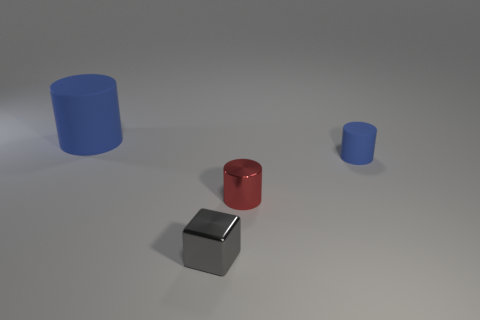Does the small gray block have the same material as the tiny red thing?
Offer a very short reply. Yes. What is the size of the other blue thing that is the same shape as the small matte object?
Provide a short and direct response. Large. Does the matte thing that is to the left of the small matte cylinder have the same shape as the tiny object that is to the left of the red cylinder?
Offer a terse response. No. Does the gray metal cube have the same size as the blue rubber object that is right of the tiny shiny cube?
Provide a short and direct response. Yes. What number of other objects are there of the same material as the tiny block?
Make the answer very short. 1. Is there any other thing that has the same shape as the tiny blue thing?
Offer a very short reply. Yes. What color is the cylinder in front of the blue cylinder in front of the blue matte cylinder that is left of the tiny gray thing?
Make the answer very short. Red. There is a tiny object that is on the right side of the tiny gray thing and to the left of the tiny rubber thing; what shape is it?
Your response must be concise. Cylinder. What is the color of the cylinder that is behind the rubber cylinder right of the large rubber cylinder?
Offer a terse response. Blue. There is a blue object that is in front of the blue matte object on the left side of the shiny thing that is behind the gray metal cube; what shape is it?
Make the answer very short. Cylinder. 